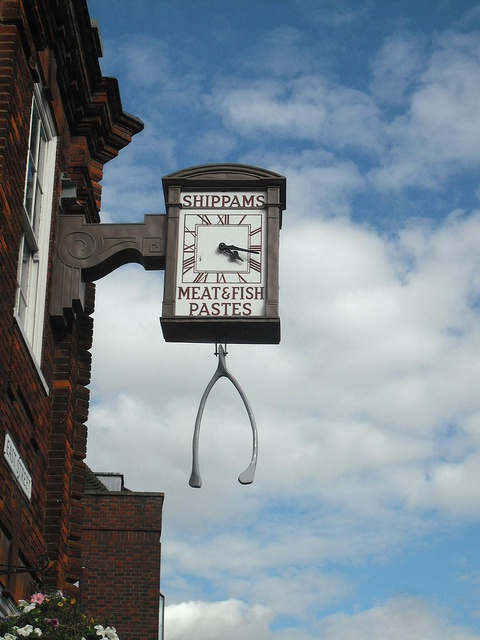Describe the objects in this image and their specific colors. I can see a clock in black, lightgray, darkgray, and gray tones in this image. 